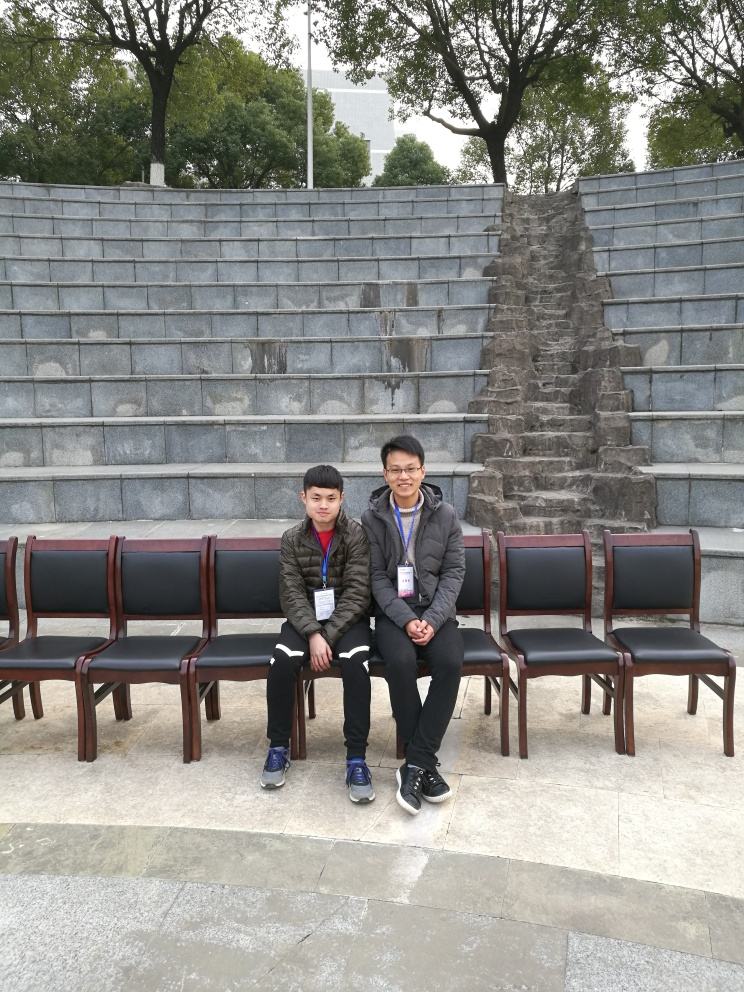Is the horizon parallel to the bottom of the frame? Upon examining the image, it seems the horizon is indeed almost parallel to the bottom frame of the image, maintaining the photograph's balance and giving a sense of stability to the scene. 